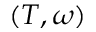<formula> <loc_0><loc_0><loc_500><loc_500>( T , \omega )</formula> 